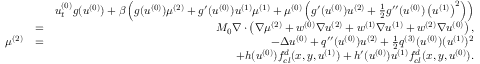<formula> <loc_0><loc_0><loc_500><loc_500>\begin{array} { r l r } & { u _ { t } ^ { ( 0 ) } g ( u ^ { ( 0 ) } ) + \beta \left ( g ( u ^ { ( 0 ) } ) \mu ^ { ( 2 ) } + g ^ { \prime } ( u ^ { ( 0 ) } ) u ^ { ( 1 ) } \mu ^ { ( 1 ) } + \mu ^ { ( 0 ) } \left ( g ^ { \prime } ( u ^ { ( 0 ) } ) u ^ { ( 2 ) } + \frac { 1 } { 2 } g ^ { \prime \prime } ( u ^ { ( 0 ) } ) \left ( u ^ { ( 1 ) } \right ) ^ { 2 } \right ) \right ) } \\ & { = } & { M _ { 0 } \nabla \cdot \left ( \nabla \mu ^ { ( 2 ) } + w ^ { ( 0 ) } \nabla u ^ { ( 2 ) } + w ^ { ( 1 ) } \nabla u ^ { ( 1 ) } + w ^ { ( 2 ) } \nabla u ^ { ( 0 ) } \right ) , } \\ { \mu ^ { ( 2 ) } } & { = } & { - \Delta u ^ { ( 0 ) } + q ^ { \prime \prime } ( u ^ { ( 0 ) } ) u ^ { ( 2 ) } + \frac { 1 } { 2 } q ^ { ( 3 ) } ( u ^ { ( 0 ) } ) ( u ^ { ( 1 ) } ) ^ { 2 } } \\ & { + h ( u ^ { ( 0 ) } ) f _ { c l } ^ { d } ( x , y , u ^ { ( 1 ) } ) + h ^ { \prime } ( u ^ { ( 0 ) } ) u ^ { ( 1 ) } f _ { c l } ^ { d } ( x , y , u ^ { ( 0 ) } ) . } \end{array}</formula> 